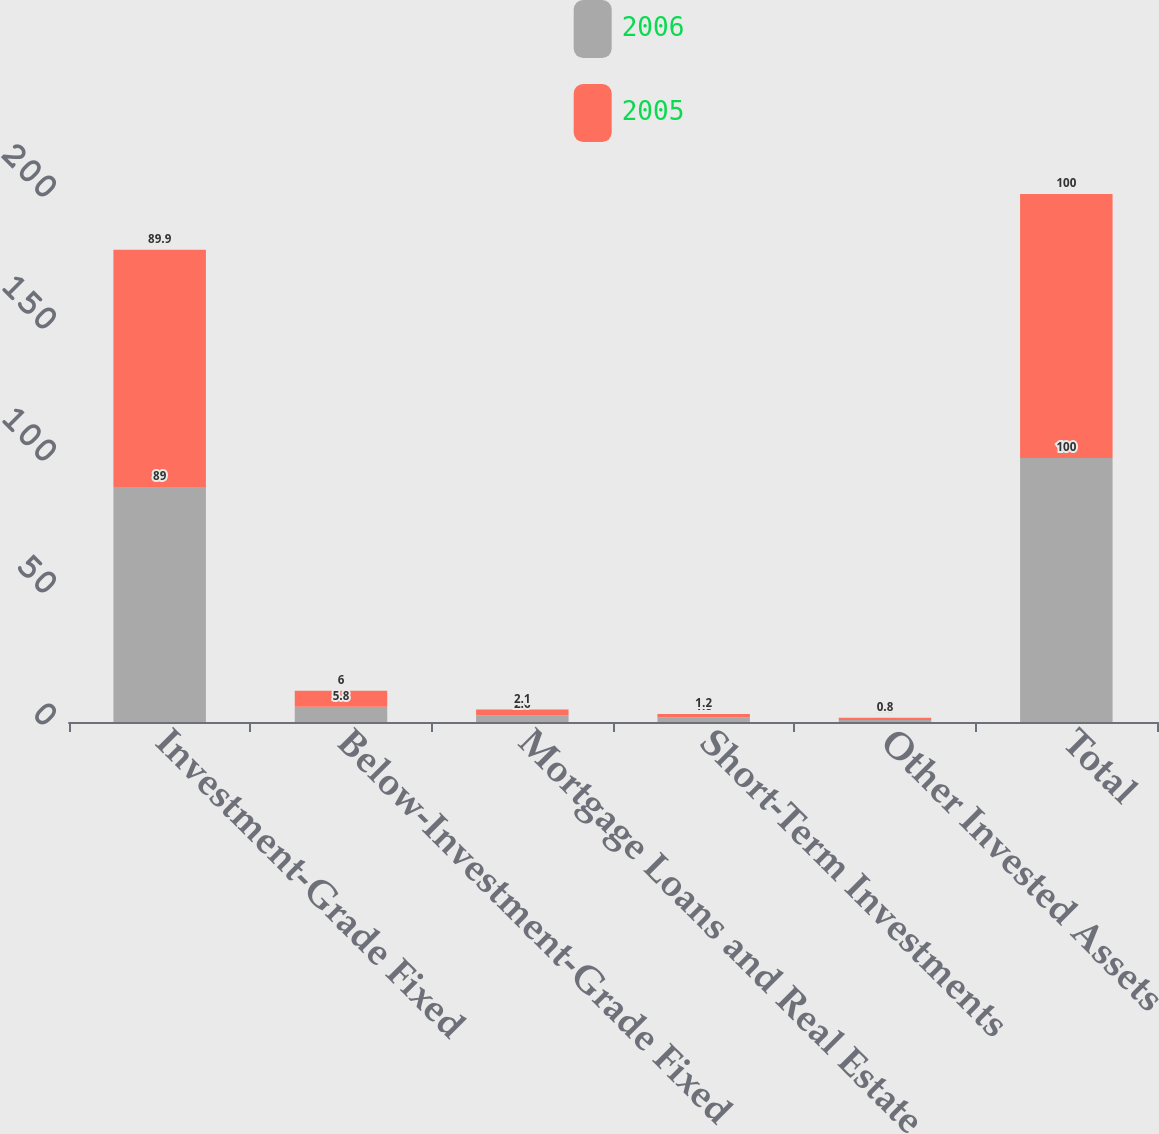Convert chart. <chart><loc_0><loc_0><loc_500><loc_500><stacked_bar_chart><ecel><fcel>Investment-Grade Fixed<fcel>Below-Investment-Grade Fixed<fcel>Mortgage Loans and Real Estate<fcel>Short-Term Investments<fcel>Other Invested Assets<fcel>Total<nl><fcel>2006<fcel>89<fcel>5.8<fcel>2.6<fcel>1.8<fcel>0.8<fcel>100<nl><fcel>2005<fcel>89.9<fcel>6<fcel>2.1<fcel>1.2<fcel>0.8<fcel>100<nl></chart> 